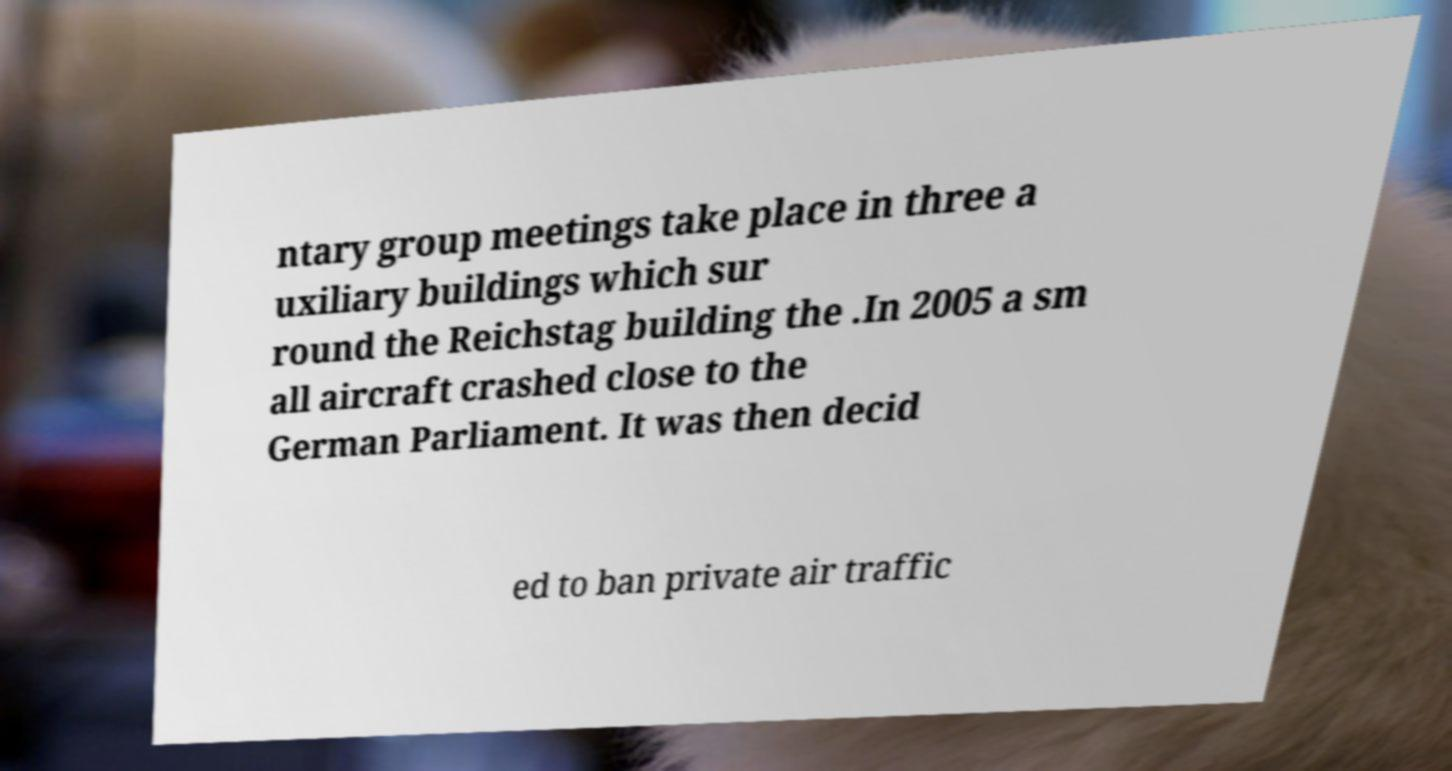Could you extract and type out the text from this image? ntary group meetings take place in three a uxiliary buildings which sur round the Reichstag building the .In 2005 a sm all aircraft crashed close to the German Parliament. It was then decid ed to ban private air traffic 